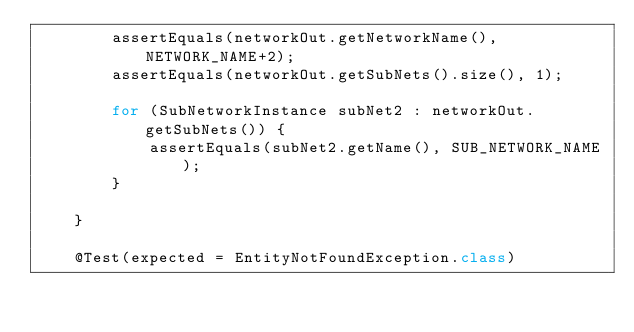Convert code to text. <code><loc_0><loc_0><loc_500><loc_500><_Java_>        assertEquals(networkOut.getNetworkName(), NETWORK_NAME+2);
        assertEquals(networkOut.getSubNets().size(), 1);

        for (SubNetworkInstance subNet2 : networkOut.getSubNets()) {
            assertEquals(subNet2.getName(), SUB_NETWORK_NAME);
        }

    }

    @Test(expected = EntityNotFoundException.class)</code> 